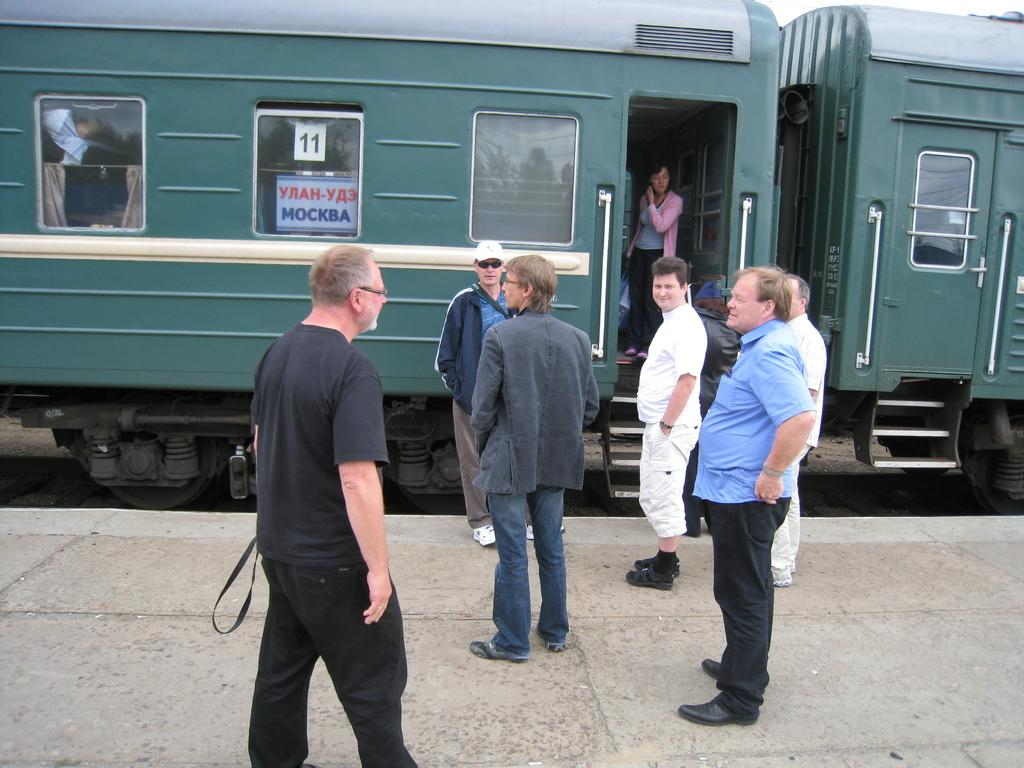What can be seen at the bottom of the image? There is a group of persons standing at the bottom of the image. What is visible in the background of the image? There is a train in the background of the image. Can you describe the woman in the image? There is a woman standing inside the train. What type of game is the woman playing with the zebra in the image? There is no game or zebra present in the image. Is the woman in the image a lawyer? The provided facts do not mention the woman's profession, so it cannot be determined if she is a lawyer. 